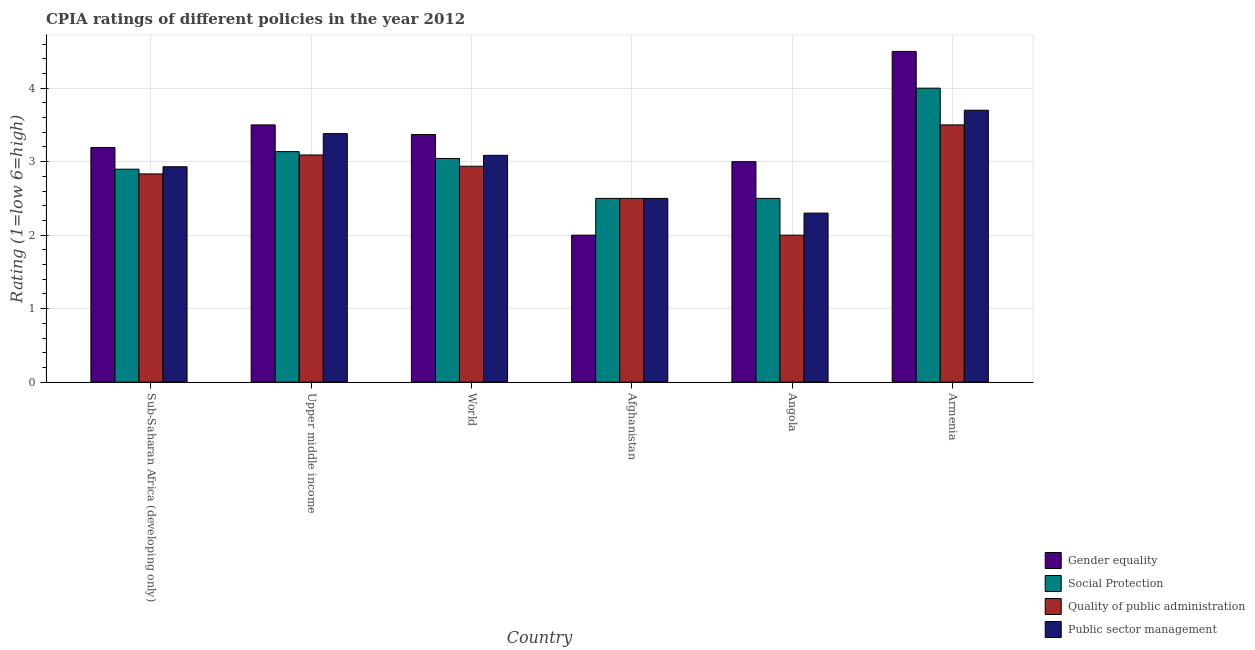How many different coloured bars are there?
Provide a succinct answer. 4. How many groups of bars are there?
Make the answer very short. 6. Are the number of bars on each tick of the X-axis equal?
Your response must be concise. Yes. How many bars are there on the 5th tick from the left?
Make the answer very short. 4. What is the label of the 6th group of bars from the left?
Make the answer very short. Armenia. In how many cases, is the number of bars for a given country not equal to the number of legend labels?
Ensure brevity in your answer.  0. Across all countries, what is the maximum cpia rating of public sector management?
Ensure brevity in your answer.  3.7. In which country was the cpia rating of public sector management maximum?
Provide a succinct answer. Armenia. In which country was the cpia rating of gender equality minimum?
Your answer should be very brief. Afghanistan. What is the total cpia rating of gender equality in the graph?
Provide a succinct answer. 19.56. What is the difference between the cpia rating of social protection in Afghanistan and that in Upper middle income?
Your response must be concise. -0.64. What is the difference between the cpia rating of public sector management in Upper middle income and the cpia rating of social protection in World?
Make the answer very short. 0.34. What is the average cpia rating of social protection per country?
Offer a very short reply. 3.01. What is the difference between the cpia rating of gender equality and cpia rating of public sector management in World?
Provide a short and direct response. 0.28. What is the ratio of the cpia rating of public sector management in Sub-Saharan Africa (developing only) to that in Upper middle income?
Ensure brevity in your answer.  0.87. Is the cpia rating of social protection in Afghanistan less than that in Armenia?
Your response must be concise. Yes. Is the difference between the cpia rating of quality of public administration in Afghanistan and Upper middle income greater than the difference between the cpia rating of public sector management in Afghanistan and Upper middle income?
Provide a succinct answer. Yes. What is the difference between the highest and the second highest cpia rating of gender equality?
Offer a very short reply. 1. Is the sum of the cpia rating of gender equality in Angola and Sub-Saharan Africa (developing only) greater than the maximum cpia rating of quality of public administration across all countries?
Your answer should be very brief. Yes. Is it the case that in every country, the sum of the cpia rating of social protection and cpia rating of quality of public administration is greater than the sum of cpia rating of gender equality and cpia rating of public sector management?
Your answer should be very brief. No. What does the 3rd bar from the left in Upper middle income represents?
Keep it short and to the point. Quality of public administration. What does the 4th bar from the right in Armenia represents?
Your answer should be very brief. Gender equality. How many countries are there in the graph?
Offer a terse response. 6. Are the values on the major ticks of Y-axis written in scientific E-notation?
Provide a succinct answer. No. Does the graph contain grids?
Keep it short and to the point. Yes. Where does the legend appear in the graph?
Your answer should be very brief. Bottom right. How many legend labels are there?
Offer a terse response. 4. How are the legend labels stacked?
Give a very brief answer. Vertical. What is the title of the graph?
Your answer should be compact. CPIA ratings of different policies in the year 2012. What is the label or title of the X-axis?
Ensure brevity in your answer.  Country. What is the label or title of the Y-axis?
Keep it short and to the point. Rating (1=low 6=high). What is the Rating (1=low 6=high) of Gender equality in Sub-Saharan Africa (developing only)?
Your response must be concise. 3.19. What is the Rating (1=low 6=high) in Social Protection in Sub-Saharan Africa (developing only)?
Keep it short and to the point. 2.9. What is the Rating (1=low 6=high) of Quality of public administration in Sub-Saharan Africa (developing only)?
Your response must be concise. 2.83. What is the Rating (1=low 6=high) in Public sector management in Sub-Saharan Africa (developing only)?
Your answer should be compact. 2.93. What is the Rating (1=low 6=high) in Gender equality in Upper middle income?
Your response must be concise. 3.5. What is the Rating (1=low 6=high) of Social Protection in Upper middle income?
Your response must be concise. 3.14. What is the Rating (1=low 6=high) in Quality of public administration in Upper middle income?
Offer a very short reply. 3.09. What is the Rating (1=low 6=high) of Public sector management in Upper middle income?
Provide a succinct answer. 3.38. What is the Rating (1=low 6=high) of Gender equality in World?
Your answer should be compact. 3.37. What is the Rating (1=low 6=high) in Social Protection in World?
Your answer should be compact. 3.04. What is the Rating (1=low 6=high) of Quality of public administration in World?
Provide a short and direct response. 2.94. What is the Rating (1=low 6=high) of Public sector management in World?
Your answer should be compact. 3.09. What is the Rating (1=low 6=high) in Gender equality in Afghanistan?
Keep it short and to the point. 2. What is the Rating (1=low 6=high) of Social Protection in Afghanistan?
Ensure brevity in your answer.  2.5. What is the Rating (1=low 6=high) in Social Protection in Angola?
Provide a short and direct response. 2.5. What is the Rating (1=low 6=high) of Public sector management in Angola?
Your response must be concise. 2.3. What is the Rating (1=low 6=high) in Gender equality in Armenia?
Provide a succinct answer. 4.5. What is the Rating (1=low 6=high) in Social Protection in Armenia?
Keep it short and to the point. 4. What is the Rating (1=low 6=high) of Quality of public administration in Armenia?
Make the answer very short. 3.5. What is the Rating (1=low 6=high) of Public sector management in Armenia?
Offer a terse response. 3.7. Across all countries, what is the maximum Rating (1=low 6=high) in Social Protection?
Make the answer very short. 4. Across all countries, what is the maximum Rating (1=low 6=high) of Quality of public administration?
Keep it short and to the point. 3.5. Across all countries, what is the maximum Rating (1=low 6=high) in Public sector management?
Provide a succinct answer. 3.7. Across all countries, what is the minimum Rating (1=low 6=high) of Quality of public administration?
Provide a short and direct response. 2. What is the total Rating (1=low 6=high) of Gender equality in the graph?
Keep it short and to the point. 19.56. What is the total Rating (1=low 6=high) in Social Protection in the graph?
Offer a terse response. 18.08. What is the total Rating (1=low 6=high) of Quality of public administration in the graph?
Give a very brief answer. 16.86. What is the total Rating (1=low 6=high) of Public sector management in the graph?
Give a very brief answer. 17.9. What is the difference between the Rating (1=low 6=high) of Gender equality in Sub-Saharan Africa (developing only) and that in Upper middle income?
Give a very brief answer. -0.31. What is the difference between the Rating (1=low 6=high) of Social Protection in Sub-Saharan Africa (developing only) and that in Upper middle income?
Give a very brief answer. -0.24. What is the difference between the Rating (1=low 6=high) in Quality of public administration in Sub-Saharan Africa (developing only) and that in Upper middle income?
Make the answer very short. -0.26. What is the difference between the Rating (1=low 6=high) of Public sector management in Sub-Saharan Africa (developing only) and that in Upper middle income?
Your answer should be very brief. -0.45. What is the difference between the Rating (1=low 6=high) of Gender equality in Sub-Saharan Africa (developing only) and that in World?
Provide a succinct answer. -0.18. What is the difference between the Rating (1=low 6=high) of Social Protection in Sub-Saharan Africa (developing only) and that in World?
Offer a very short reply. -0.15. What is the difference between the Rating (1=low 6=high) in Quality of public administration in Sub-Saharan Africa (developing only) and that in World?
Your response must be concise. -0.1. What is the difference between the Rating (1=low 6=high) of Public sector management in Sub-Saharan Africa (developing only) and that in World?
Your answer should be compact. -0.16. What is the difference between the Rating (1=low 6=high) in Gender equality in Sub-Saharan Africa (developing only) and that in Afghanistan?
Provide a short and direct response. 1.19. What is the difference between the Rating (1=low 6=high) in Social Protection in Sub-Saharan Africa (developing only) and that in Afghanistan?
Offer a terse response. 0.4. What is the difference between the Rating (1=low 6=high) of Public sector management in Sub-Saharan Africa (developing only) and that in Afghanistan?
Keep it short and to the point. 0.43. What is the difference between the Rating (1=low 6=high) in Gender equality in Sub-Saharan Africa (developing only) and that in Angola?
Ensure brevity in your answer.  0.19. What is the difference between the Rating (1=low 6=high) of Social Protection in Sub-Saharan Africa (developing only) and that in Angola?
Your answer should be compact. 0.4. What is the difference between the Rating (1=low 6=high) in Quality of public administration in Sub-Saharan Africa (developing only) and that in Angola?
Ensure brevity in your answer.  0.83. What is the difference between the Rating (1=low 6=high) of Public sector management in Sub-Saharan Africa (developing only) and that in Angola?
Provide a succinct answer. 0.63. What is the difference between the Rating (1=low 6=high) in Gender equality in Sub-Saharan Africa (developing only) and that in Armenia?
Provide a succinct answer. -1.31. What is the difference between the Rating (1=low 6=high) in Social Protection in Sub-Saharan Africa (developing only) and that in Armenia?
Provide a short and direct response. -1.1. What is the difference between the Rating (1=low 6=high) in Quality of public administration in Sub-Saharan Africa (developing only) and that in Armenia?
Offer a terse response. -0.67. What is the difference between the Rating (1=low 6=high) of Public sector management in Sub-Saharan Africa (developing only) and that in Armenia?
Provide a succinct answer. -0.77. What is the difference between the Rating (1=low 6=high) in Gender equality in Upper middle income and that in World?
Ensure brevity in your answer.  0.13. What is the difference between the Rating (1=low 6=high) in Social Protection in Upper middle income and that in World?
Provide a short and direct response. 0.09. What is the difference between the Rating (1=low 6=high) in Quality of public administration in Upper middle income and that in World?
Give a very brief answer. 0.15. What is the difference between the Rating (1=low 6=high) in Public sector management in Upper middle income and that in World?
Make the answer very short. 0.3. What is the difference between the Rating (1=low 6=high) of Gender equality in Upper middle income and that in Afghanistan?
Give a very brief answer. 1.5. What is the difference between the Rating (1=low 6=high) of Social Protection in Upper middle income and that in Afghanistan?
Provide a short and direct response. 0.64. What is the difference between the Rating (1=low 6=high) of Quality of public administration in Upper middle income and that in Afghanistan?
Your answer should be very brief. 0.59. What is the difference between the Rating (1=low 6=high) in Public sector management in Upper middle income and that in Afghanistan?
Your response must be concise. 0.88. What is the difference between the Rating (1=low 6=high) of Social Protection in Upper middle income and that in Angola?
Provide a short and direct response. 0.64. What is the difference between the Rating (1=low 6=high) of Public sector management in Upper middle income and that in Angola?
Provide a succinct answer. 1.08. What is the difference between the Rating (1=low 6=high) in Gender equality in Upper middle income and that in Armenia?
Your response must be concise. -1. What is the difference between the Rating (1=low 6=high) in Social Protection in Upper middle income and that in Armenia?
Ensure brevity in your answer.  -0.86. What is the difference between the Rating (1=low 6=high) in Quality of public administration in Upper middle income and that in Armenia?
Give a very brief answer. -0.41. What is the difference between the Rating (1=low 6=high) in Public sector management in Upper middle income and that in Armenia?
Offer a very short reply. -0.32. What is the difference between the Rating (1=low 6=high) in Gender equality in World and that in Afghanistan?
Give a very brief answer. 1.37. What is the difference between the Rating (1=low 6=high) of Social Protection in World and that in Afghanistan?
Give a very brief answer. 0.54. What is the difference between the Rating (1=low 6=high) of Quality of public administration in World and that in Afghanistan?
Offer a very short reply. 0.44. What is the difference between the Rating (1=low 6=high) in Public sector management in World and that in Afghanistan?
Ensure brevity in your answer.  0.59. What is the difference between the Rating (1=low 6=high) of Gender equality in World and that in Angola?
Your answer should be compact. 0.37. What is the difference between the Rating (1=low 6=high) of Social Protection in World and that in Angola?
Offer a terse response. 0.54. What is the difference between the Rating (1=low 6=high) in Public sector management in World and that in Angola?
Ensure brevity in your answer.  0.79. What is the difference between the Rating (1=low 6=high) in Gender equality in World and that in Armenia?
Make the answer very short. -1.13. What is the difference between the Rating (1=low 6=high) of Social Protection in World and that in Armenia?
Provide a succinct answer. -0.96. What is the difference between the Rating (1=low 6=high) of Quality of public administration in World and that in Armenia?
Give a very brief answer. -0.56. What is the difference between the Rating (1=low 6=high) in Public sector management in World and that in Armenia?
Offer a terse response. -0.61. What is the difference between the Rating (1=low 6=high) in Social Protection in Afghanistan and that in Angola?
Provide a succinct answer. 0. What is the difference between the Rating (1=low 6=high) in Public sector management in Afghanistan and that in Angola?
Make the answer very short. 0.2. What is the difference between the Rating (1=low 6=high) of Gender equality in Afghanistan and that in Armenia?
Your answer should be very brief. -2.5. What is the difference between the Rating (1=low 6=high) in Gender equality in Angola and that in Armenia?
Offer a very short reply. -1.5. What is the difference between the Rating (1=low 6=high) in Gender equality in Sub-Saharan Africa (developing only) and the Rating (1=low 6=high) in Social Protection in Upper middle income?
Offer a very short reply. 0.06. What is the difference between the Rating (1=low 6=high) of Gender equality in Sub-Saharan Africa (developing only) and the Rating (1=low 6=high) of Quality of public administration in Upper middle income?
Offer a terse response. 0.1. What is the difference between the Rating (1=low 6=high) in Gender equality in Sub-Saharan Africa (developing only) and the Rating (1=low 6=high) in Public sector management in Upper middle income?
Provide a short and direct response. -0.19. What is the difference between the Rating (1=low 6=high) of Social Protection in Sub-Saharan Africa (developing only) and the Rating (1=low 6=high) of Quality of public administration in Upper middle income?
Ensure brevity in your answer.  -0.19. What is the difference between the Rating (1=low 6=high) in Social Protection in Sub-Saharan Africa (developing only) and the Rating (1=low 6=high) in Public sector management in Upper middle income?
Provide a short and direct response. -0.48. What is the difference between the Rating (1=low 6=high) of Quality of public administration in Sub-Saharan Africa (developing only) and the Rating (1=low 6=high) of Public sector management in Upper middle income?
Make the answer very short. -0.55. What is the difference between the Rating (1=low 6=high) in Gender equality in Sub-Saharan Africa (developing only) and the Rating (1=low 6=high) in Social Protection in World?
Offer a very short reply. 0.15. What is the difference between the Rating (1=low 6=high) in Gender equality in Sub-Saharan Africa (developing only) and the Rating (1=low 6=high) in Quality of public administration in World?
Ensure brevity in your answer.  0.25. What is the difference between the Rating (1=low 6=high) of Gender equality in Sub-Saharan Africa (developing only) and the Rating (1=low 6=high) of Public sector management in World?
Provide a succinct answer. 0.11. What is the difference between the Rating (1=low 6=high) of Social Protection in Sub-Saharan Africa (developing only) and the Rating (1=low 6=high) of Quality of public administration in World?
Offer a terse response. -0.04. What is the difference between the Rating (1=low 6=high) of Social Protection in Sub-Saharan Africa (developing only) and the Rating (1=low 6=high) of Public sector management in World?
Offer a very short reply. -0.19. What is the difference between the Rating (1=low 6=high) of Quality of public administration in Sub-Saharan Africa (developing only) and the Rating (1=low 6=high) of Public sector management in World?
Provide a succinct answer. -0.25. What is the difference between the Rating (1=low 6=high) of Gender equality in Sub-Saharan Africa (developing only) and the Rating (1=low 6=high) of Social Protection in Afghanistan?
Ensure brevity in your answer.  0.69. What is the difference between the Rating (1=low 6=high) in Gender equality in Sub-Saharan Africa (developing only) and the Rating (1=low 6=high) in Quality of public administration in Afghanistan?
Offer a terse response. 0.69. What is the difference between the Rating (1=low 6=high) in Gender equality in Sub-Saharan Africa (developing only) and the Rating (1=low 6=high) in Public sector management in Afghanistan?
Give a very brief answer. 0.69. What is the difference between the Rating (1=low 6=high) in Social Protection in Sub-Saharan Africa (developing only) and the Rating (1=low 6=high) in Quality of public administration in Afghanistan?
Give a very brief answer. 0.4. What is the difference between the Rating (1=low 6=high) of Social Protection in Sub-Saharan Africa (developing only) and the Rating (1=low 6=high) of Public sector management in Afghanistan?
Offer a terse response. 0.4. What is the difference between the Rating (1=low 6=high) of Gender equality in Sub-Saharan Africa (developing only) and the Rating (1=low 6=high) of Social Protection in Angola?
Give a very brief answer. 0.69. What is the difference between the Rating (1=low 6=high) of Gender equality in Sub-Saharan Africa (developing only) and the Rating (1=low 6=high) of Quality of public administration in Angola?
Your answer should be compact. 1.19. What is the difference between the Rating (1=low 6=high) in Gender equality in Sub-Saharan Africa (developing only) and the Rating (1=low 6=high) in Public sector management in Angola?
Your answer should be compact. 0.89. What is the difference between the Rating (1=low 6=high) of Social Protection in Sub-Saharan Africa (developing only) and the Rating (1=low 6=high) of Quality of public administration in Angola?
Ensure brevity in your answer.  0.9. What is the difference between the Rating (1=low 6=high) of Social Protection in Sub-Saharan Africa (developing only) and the Rating (1=low 6=high) of Public sector management in Angola?
Provide a succinct answer. 0.6. What is the difference between the Rating (1=low 6=high) of Quality of public administration in Sub-Saharan Africa (developing only) and the Rating (1=low 6=high) of Public sector management in Angola?
Ensure brevity in your answer.  0.53. What is the difference between the Rating (1=low 6=high) of Gender equality in Sub-Saharan Africa (developing only) and the Rating (1=low 6=high) of Social Protection in Armenia?
Ensure brevity in your answer.  -0.81. What is the difference between the Rating (1=low 6=high) of Gender equality in Sub-Saharan Africa (developing only) and the Rating (1=low 6=high) of Quality of public administration in Armenia?
Provide a succinct answer. -0.31. What is the difference between the Rating (1=low 6=high) in Gender equality in Sub-Saharan Africa (developing only) and the Rating (1=low 6=high) in Public sector management in Armenia?
Your answer should be compact. -0.51. What is the difference between the Rating (1=low 6=high) of Social Protection in Sub-Saharan Africa (developing only) and the Rating (1=low 6=high) of Quality of public administration in Armenia?
Your response must be concise. -0.6. What is the difference between the Rating (1=low 6=high) of Social Protection in Sub-Saharan Africa (developing only) and the Rating (1=low 6=high) of Public sector management in Armenia?
Ensure brevity in your answer.  -0.8. What is the difference between the Rating (1=low 6=high) in Quality of public administration in Sub-Saharan Africa (developing only) and the Rating (1=low 6=high) in Public sector management in Armenia?
Provide a short and direct response. -0.87. What is the difference between the Rating (1=low 6=high) of Gender equality in Upper middle income and the Rating (1=low 6=high) of Social Protection in World?
Provide a short and direct response. 0.46. What is the difference between the Rating (1=low 6=high) of Gender equality in Upper middle income and the Rating (1=low 6=high) of Quality of public administration in World?
Keep it short and to the point. 0.56. What is the difference between the Rating (1=low 6=high) in Gender equality in Upper middle income and the Rating (1=low 6=high) in Public sector management in World?
Provide a succinct answer. 0.41. What is the difference between the Rating (1=low 6=high) in Social Protection in Upper middle income and the Rating (1=low 6=high) in Quality of public administration in World?
Keep it short and to the point. 0.2. What is the difference between the Rating (1=low 6=high) of Social Protection in Upper middle income and the Rating (1=low 6=high) of Public sector management in World?
Give a very brief answer. 0.05. What is the difference between the Rating (1=low 6=high) of Quality of public administration in Upper middle income and the Rating (1=low 6=high) of Public sector management in World?
Your answer should be very brief. 0. What is the difference between the Rating (1=low 6=high) of Gender equality in Upper middle income and the Rating (1=low 6=high) of Quality of public administration in Afghanistan?
Ensure brevity in your answer.  1. What is the difference between the Rating (1=low 6=high) of Gender equality in Upper middle income and the Rating (1=low 6=high) of Public sector management in Afghanistan?
Ensure brevity in your answer.  1. What is the difference between the Rating (1=low 6=high) of Social Protection in Upper middle income and the Rating (1=low 6=high) of Quality of public administration in Afghanistan?
Make the answer very short. 0.64. What is the difference between the Rating (1=low 6=high) of Social Protection in Upper middle income and the Rating (1=low 6=high) of Public sector management in Afghanistan?
Offer a very short reply. 0.64. What is the difference between the Rating (1=low 6=high) in Quality of public administration in Upper middle income and the Rating (1=low 6=high) in Public sector management in Afghanistan?
Your answer should be very brief. 0.59. What is the difference between the Rating (1=low 6=high) in Gender equality in Upper middle income and the Rating (1=low 6=high) in Social Protection in Angola?
Offer a very short reply. 1. What is the difference between the Rating (1=low 6=high) of Gender equality in Upper middle income and the Rating (1=low 6=high) of Public sector management in Angola?
Ensure brevity in your answer.  1.2. What is the difference between the Rating (1=low 6=high) of Social Protection in Upper middle income and the Rating (1=low 6=high) of Quality of public administration in Angola?
Offer a terse response. 1.14. What is the difference between the Rating (1=low 6=high) of Social Protection in Upper middle income and the Rating (1=low 6=high) of Public sector management in Angola?
Keep it short and to the point. 0.84. What is the difference between the Rating (1=low 6=high) of Quality of public administration in Upper middle income and the Rating (1=low 6=high) of Public sector management in Angola?
Ensure brevity in your answer.  0.79. What is the difference between the Rating (1=low 6=high) of Gender equality in Upper middle income and the Rating (1=low 6=high) of Social Protection in Armenia?
Give a very brief answer. -0.5. What is the difference between the Rating (1=low 6=high) of Gender equality in Upper middle income and the Rating (1=low 6=high) of Public sector management in Armenia?
Give a very brief answer. -0.2. What is the difference between the Rating (1=low 6=high) in Social Protection in Upper middle income and the Rating (1=low 6=high) in Quality of public administration in Armenia?
Make the answer very short. -0.36. What is the difference between the Rating (1=low 6=high) of Social Protection in Upper middle income and the Rating (1=low 6=high) of Public sector management in Armenia?
Your answer should be compact. -0.56. What is the difference between the Rating (1=low 6=high) of Quality of public administration in Upper middle income and the Rating (1=low 6=high) of Public sector management in Armenia?
Keep it short and to the point. -0.61. What is the difference between the Rating (1=low 6=high) in Gender equality in World and the Rating (1=low 6=high) in Social Protection in Afghanistan?
Your response must be concise. 0.87. What is the difference between the Rating (1=low 6=high) of Gender equality in World and the Rating (1=low 6=high) of Quality of public administration in Afghanistan?
Ensure brevity in your answer.  0.87. What is the difference between the Rating (1=low 6=high) of Gender equality in World and the Rating (1=low 6=high) of Public sector management in Afghanistan?
Give a very brief answer. 0.87. What is the difference between the Rating (1=low 6=high) of Social Protection in World and the Rating (1=low 6=high) of Quality of public administration in Afghanistan?
Offer a very short reply. 0.54. What is the difference between the Rating (1=low 6=high) of Social Protection in World and the Rating (1=low 6=high) of Public sector management in Afghanistan?
Make the answer very short. 0.54. What is the difference between the Rating (1=low 6=high) of Quality of public administration in World and the Rating (1=low 6=high) of Public sector management in Afghanistan?
Offer a terse response. 0.44. What is the difference between the Rating (1=low 6=high) in Gender equality in World and the Rating (1=low 6=high) in Social Protection in Angola?
Provide a short and direct response. 0.87. What is the difference between the Rating (1=low 6=high) of Gender equality in World and the Rating (1=low 6=high) of Quality of public administration in Angola?
Keep it short and to the point. 1.37. What is the difference between the Rating (1=low 6=high) in Gender equality in World and the Rating (1=low 6=high) in Public sector management in Angola?
Provide a succinct answer. 1.07. What is the difference between the Rating (1=low 6=high) in Social Protection in World and the Rating (1=low 6=high) in Quality of public administration in Angola?
Provide a succinct answer. 1.04. What is the difference between the Rating (1=low 6=high) of Social Protection in World and the Rating (1=low 6=high) of Public sector management in Angola?
Your answer should be compact. 0.74. What is the difference between the Rating (1=low 6=high) in Quality of public administration in World and the Rating (1=low 6=high) in Public sector management in Angola?
Provide a succinct answer. 0.64. What is the difference between the Rating (1=low 6=high) of Gender equality in World and the Rating (1=low 6=high) of Social Protection in Armenia?
Offer a terse response. -0.63. What is the difference between the Rating (1=low 6=high) of Gender equality in World and the Rating (1=low 6=high) of Quality of public administration in Armenia?
Your answer should be very brief. -0.13. What is the difference between the Rating (1=low 6=high) in Gender equality in World and the Rating (1=low 6=high) in Public sector management in Armenia?
Ensure brevity in your answer.  -0.33. What is the difference between the Rating (1=low 6=high) in Social Protection in World and the Rating (1=low 6=high) in Quality of public administration in Armenia?
Ensure brevity in your answer.  -0.46. What is the difference between the Rating (1=low 6=high) of Social Protection in World and the Rating (1=low 6=high) of Public sector management in Armenia?
Offer a very short reply. -0.66. What is the difference between the Rating (1=low 6=high) in Quality of public administration in World and the Rating (1=low 6=high) in Public sector management in Armenia?
Offer a terse response. -0.76. What is the difference between the Rating (1=low 6=high) in Gender equality in Afghanistan and the Rating (1=low 6=high) in Social Protection in Angola?
Your answer should be very brief. -0.5. What is the difference between the Rating (1=low 6=high) of Gender equality in Afghanistan and the Rating (1=low 6=high) of Quality of public administration in Angola?
Provide a short and direct response. 0. What is the difference between the Rating (1=low 6=high) of Social Protection in Afghanistan and the Rating (1=low 6=high) of Public sector management in Angola?
Provide a short and direct response. 0.2. What is the difference between the Rating (1=low 6=high) of Quality of public administration in Afghanistan and the Rating (1=low 6=high) of Public sector management in Angola?
Give a very brief answer. 0.2. What is the difference between the Rating (1=low 6=high) of Gender equality in Afghanistan and the Rating (1=low 6=high) of Social Protection in Armenia?
Your response must be concise. -2. What is the difference between the Rating (1=low 6=high) in Gender equality in Afghanistan and the Rating (1=low 6=high) in Public sector management in Armenia?
Your answer should be compact. -1.7. What is the difference between the Rating (1=low 6=high) in Social Protection in Afghanistan and the Rating (1=low 6=high) in Public sector management in Armenia?
Provide a succinct answer. -1.2. What is the difference between the Rating (1=low 6=high) in Quality of public administration in Afghanistan and the Rating (1=low 6=high) in Public sector management in Armenia?
Give a very brief answer. -1.2. What is the difference between the Rating (1=low 6=high) of Gender equality in Angola and the Rating (1=low 6=high) of Social Protection in Armenia?
Offer a terse response. -1. What is the difference between the Rating (1=low 6=high) of Gender equality in Angola and the Rating (1=low 6=high) of Quality of public administration in Armenia?
Provide a short and direct response. -0.5. What is the difference between the Rating (1=low 6=high) of Gender equality in Angola and the Rating (1=low 6=high) of Public sector management in Armenia?
Keep it short and to the point. -0.7. What is the difference between the Rating (1=low 6=high) in Social Protection in Angola and the Rating (1=low 6=high) in Quality of public administration in Armenia?
Your response must be concise. -1. What is the difference between the Rating (1=low 6=high) of Social Protection in Angola and the Rating (1=low 6=high) of Public sector management in Armenia?
Your response must be concise. -1.2. What is the difference between the Rating (1=low 6=high) of Quality of public administration in Angola and the Rating (1=low 6=high) of Public sector management in Armenia?
Make the answer very short. -1.7. What is the average Rating (1=low 6=high) of Gender equality per country?
Provide a short and direct response. 3.26. What is the average Rating (1=low 6=high) in Social Protection per country?
Keep it short and to the point. 3.01. What is the average Rating (1=low 6=high) in Quality of public administration per country?
Provide a short and direct response. 2.81. What is the average Rating (1=low 6=high) in Public sector management per country?
Your response must be concise. 2.98. What is the difference between the Rating (1=low 6=high) of Gender equality and Rating (1=low 6=high) of Social Protection in Sub-Saharan Africa (developing only)?
Keep it short and to the point. 0.29. What is the difference between the Rating (1=low 6=high) in Gender equality and Rating (1=low 6=high) in Quality of public administration in Sub-Saharan Africa (developing only)?
Offer a very short reply. 0.36. What is the difference between the Rating (1=low 6=high) in Gender equality and Rating (1=low 6=high) in Public sector management in Sub-Saharan Africa (developing only)?
Offer a very short reply. 0.26. What is the difference between the Rating (1=low 6=high) of Social Protection and Rating (1=low 6=high) of Quality of public administration in Sub-Saharan Africa (developing only)?
Provide a short and direct response. 0.06. What is the difference between the Rating (1=low 6=high) in Social Protection and Rating (1=low 6=high) in Public sector management in Sub-Saharan Africa (developing only)?
Give a very brief answer. -0.03. What is the difference between the Rating (1=low 6=high) in Quality of public administration and Rating (1=low 6=high) in Public sector management in Sub-Saharan Africa (developing only)?
Provide a short and direct response. -0.1. What is the difference between the Rating (1=low 6=high) of Gender equality and Rating (1=low 6=high) of Social Protection in Upper middle income?
Your answer should be very brief. 0.36. What is the difference between the Rating (1=low 6=high) of Gender equality and Rating (1=low 6=high) of Quality of public administration in Upper middle income?
Ensure brevity in your answer.  0.41. What is the difference between the Rating (1=low 6=high) of Gender equality and Rating (1=low 6=high) of Public sector management in Upper middle income?
Make the answer very short. 0.12. What is the difference between the Rating (1=low 6=high) of Social Protection and Rating (1=low 6=high) of Quality of public administration in Upper middle income?
Offer a very short reply. 0.05. What is the difference between the Rating (1=low 6=high) in Social Protection and Rating (1=low 6=high) in Public sector management in Upper middle income?
Your answer should be compact. -0.25. What is the difference between the Rating (1=low 6=high) in Quality of public administration and Rating (1=low 6=high) in Public sector management in Upper middle income?
Offer a very short reply. -0.29. What is the difference between the Rating (1=low 6=high) of Gender equality and Rating (1=low 6=high) of Social Protection in World?
Your answer should be very brief. 0.33. What is the difference between the Rating (1=low 6=high) of Gender equality and Rating (1=low 6=high) of Quality of public administration in World?
Ensure brevity in your answer.  0.43. What is the difference between the Rating (1=low 6=high) of Gender equality and Rating (1=low 6=high) of Public sector management in World?
Provide a short and direct response. 0.28. What is the difference between the Rating (1=low 6=high) in Social Protection and Rating (1=low 6=high) in Quality of public administration in World?
Keep it short and to the point. 0.11. What is the difference between the Rating (1=low 6=high) of Social Protection and Rating (1=low 6=high) of Public sector management in World?
Offer a terse response. -0.04. What is the difference between the Rating (1=low 6=high) in Quality of public administration and Rating (1=low 6=high) in Public sector management in World?
Your answer should be compact. -0.15. What is the difference between the Rating (1=low 6=high) of Gender equality and Rating (1=low 6=high) of Social Protection in Afghanistan?
Keep it short and to the point. -0.5. What is the difference between the Rating (1=low 6=high) in Gender equality and Rating (1=low 6=high) in Quality of public administration in Afghanistan?
Your answer should be very brief. -0.5. What is the difference between the Rating (1=low 6=high) of Gender equality and Rating (1=low 6=high) of Public sector management in Afghanistan?
Your answer should be very brief. -0.5. What is the difference between the Rating (1=low 6=high) of Social Protection and Rating (1=low 6=high) of Quality of public administration in Afghanistan?
Provide a succinct answer. 0. What is the difference between the Rating (1=low 6=high) in Social Protection and Rating (1=low 6=high) in Quality of public administration in Angola?
Keep it short and to the point. 0.5. What is the difference between the Rating (1=low 6=high) in Social Protection and Rating (1=low 6=high) in Public sector management in Angola?
Provide a short and direct response. 0.2. What is the difference between the Rating (1=low 6=high) in Quality of public administration and Rating (1=low 6=high) in Public sector management in Angola?
Offer a very short reply. -0.3. What is the difference between the Rating (1=low 6=high) in Gender equality and Rating (1=low 6=high) in Social Protection in Armenia?
Keep it short and to the point. 0.5. What is the difference between the Rating (1=low 6=high) in Gender equality and Rating (1=low 6=high) in Quality of public administration in Armenia?
Offer a very short reply. 1. What is the difference between the Rating (1=low 6=high) of Gender equality and Rating (1=low 6=high) of Public sector management in Armenia?
Your response must be concise. 0.8. What is the difference between the Rating (1=low 6=high) in Social Protection and Rating (1=low 6=high) in Quality of public administration in Armenia?
Your answer should be compact. 0.5. What is the difference between the Rating (1=low 6=high) of Quality of public administration and Rating (1=low 6=high) of Public sector management in Armenia?
Offer a terse response. -0.2. What is the ratio of the Rating (1=low 6=high) of Gender equality in Sub-Saharan Africa (developing only) to that in Upper middle income?
Offer a very short reply. 0.91. What is the ratio of the Rating (1=low 6=high) of Social Protection in Sub-Saharan Africa (developing only) to that in Upper middle income?
Offer a terse response. 0.92. What is the ratio of the Rating (1=low 6=high) of Public sector management in Sub-Saharan Africa (developing only) to that in Upper middle income?
Your response must be concise. 0.87. What is the ratio of the Rating (1=low 6=high) of Gender equality in Sub-Saharan Africa (developing only) to that in World?
Offer a very short reply. 0.95. What is the ratio of the Rating (1=low 6=high) in Social Protection in Sub-Saharan Africa (developing only) to that in World?
Give a very brief answer. 0.95. What is the ratio of the Rating (1=low 6=high) of Quality of public administration in Sub-Saharan Africa (developing only) to that in World?
Make the answer very short. 0.96. What is the ratio of the Rating (1=low 6=high) of Public sector management in Sub-Saharan Africa (developing only) to that in World?
Ensure brevity in your answer.  0.95. What is the ratio of the Rating (1=low 6=high) in Gender equality in Sub-Saharan Africa (developing only) to that in Afghanistan?
Your answer should be compact. 1.6. What is the ratio of the Rating (1=low 6=high) of Social Protection in Sub-Saharan Africa (developing only) to that in Afghanistan?
Offer a terse response. 1.16. What is the ratio of the Rating (1=low 6=high) in Quality of public administration in Sub-Saharan Africa (developing only) to that in Afghanistan?
Provide a succinct answer. 1.13. What is the ratio of the Rating (1=low 6=high) of Public sector management in Sub-Saharan Africa (developing only) to that in Afghanistan?
Your response must be concise. 1.17. What is the ratio of the Rating (1=low 6=high) of Gender equality in Sub-Saharan Africa (developing only) to that in Angola?
Your answer should be very brief. 1.06. What is the ratio of the Rating (1=low 6=high) of Social Protection in Sub-Saharan Africa (developing only) to that in Angola?
Your answer should be compact. 1.16. What is the ratio of the Rating (1=low 6=high) in Quality of public administration in Sub-Saharan Africa (developing only) to that in Angola?
Provide a succinct answer. 1.42. What is the ratio of the Rating (1=low 6=high) of Public sector management in Sub-Saharan Africa (developing only) to that in Angola?
Give a very brief answer. 1.27. What is the ratio of the Rating (1=low 6=high) in Gender equality in Sub-Saharan Africa (developing only) to that in Armenia?
Provide a short and direct response. 0.71. What is the ratio of the Rating (1=low 6=high) of Social Protection in Sub-Saharan Africa (developing only) to that in Armenia?
Your answer should be very brief. 0.72. What is the ratio of the Rating (1=low 6=high) in Quality of public administration in Sub-Saharan Africa (developing only) to that in Armenia?
Your answer should be very brief. 0.81. What is the ratio of the Rating (1=low 6=high) in Public sector management in Sub-Saharan Africa (developing only) to that in Armenia?
Give a very brief answer. 0.79. What is the ratio of the Rating (1=low 6=high) in Gender equality in Upper middle income to that in World?
Keep it short and to the point. 1.04. What is the ratio of the Rating (1=low 6=high) of Social Protection in Upper middle income to that in World?
Give a very brief answer. 1.03. What is the ratio of the Rating (1=low 6=high) of Quality of public administration in Upper middle income to that in World?
Provide a succinct answer. 1.05. What is the ratio of the Rating (1=low 6=high) of Public sector management in Upper middle income to that in World?
Offer a very short reply. 1.1. What is the ratio of the Rating (1=low 6=high) in Social Protection in Upper middle income to that in Afghanistan?
Ensure brevity in your answer.  1.25. What is the ratio of the Rating (1=low 6=high) in Quality of public administration in Upper middle income to that in Afghanistan?
Offer a terse response. 1.24. What is the ratio of the Rating (1=low 6=high) in Public sector management in Upper middle income to that in Afghanistan?
Your answer should be compact. 1.35. What is the ratio of the Rating (1=low 6=high) in Social Protection in Upper middle income to that in Angola?
Ensure brevity in your answer.  1.25. What is the ratio of the Rating (1=low 6=high) in Quality of public administration in Upper middle income to that in Angola?
Your answer should be compact. 1.55. What is the ratio of the Rating (1=low 6=high) in Public sector management in Upper middle income to that in Angola?
Keep it short and to the point. 1.47. What is the ratio of the Rating (1=low 6=high) in Social Protection in Upper middle income to that in Armenia?
Provide a short and direct response. 0.78. What is the ratio of the Rating (1=low 6=high) of Quality of public administration in Upper middle income to that in Armenia?
Your answer should be compact. 0.88. What is the ratio of the Rating (1=low 6=high) of Public sector management in Upper middle income to that in Armenia?
Ensure brevity in your answer.  0.91. What is the ratio of the Rating (1=low 6=high) in Gender equality in World to that in Afghanistan?
Provide a succinct answer. 1.68. What is the ratio of the Rating (1=low 6=high) of Social Protection in World to that in Afghanistan?
Offer a terse response. 1.22. What is the ratio of the Rating (1=low 6=high) of Quality of public administration in World to that in Afghanistan?
Your response must be concise. 1.18. What is the ratio of the Rating (1=low 6=high) of Public sector management in World to that in Afghanistan?
Offer a very short reply. 1.23. What is the ratio of the Rating (1=low 6=high) of Gender equality in World to that in Angola?
Offer a terse response. 1.12. What is the ratio of the Rating (1=low 6=high) in Social Protection in World to that in Angola?
Make the answer very short. 1.22. What is the ratio of the Rating (1=low 6=high) in Quality of public administration in World to that in Angola?
Provide a short and direct response. 1.47. What is the ratio of the Rating (1=low 6=high) of Public sector management in World to that in Angola?
Give a very brief answer. 1.34. What is the ratio of the Rating (1=low 6=high) in Gender equality in World to that in Armenia?
Your answer should be compact. 0.75. What is the ratio of the Rating (1=low 6=high) in Social Protection in World to that in Armenia?
Your answer should be compact. 0.76. What is the ratio of the Rating (1=low 6=high) in Quality of public administration in World to that in Armenia?
Offer a very short reply. 0.84. What is the ratio of the Rating (1=low 6=high) of Public sector management in World to that in Armenia?
Provide a short and direct response. 0.83. What is the ratio of the Rating (1=low 6=high) of Social Protection in Afghanistan to that in Angola?
Provide a short and direct response. 1. What is the ratio of the Rating (1=low 6=high) in Quality of public administration in Afghanistan to that in Angola?
Provide a short and direct response. 1.25. What is the ratio of the Rating (1=low 6=high) of Public sector management in Afghanistan to that in Angola?
Offer a very short reply. 1.09. What is the ratio of the Rating (1=low 6=high) in Gender equality in Afghanistan to that in Armenia?
Give a very brief answer. 0.44. What is the ratio of the Rating (1=low 6=high) in Public sector management in Afghanistan to that in Armenia?
Provide a short and direct response. 0.68. What is the ratio of the Rating (1=low 6=high) in Gender equality in Angola to that in Armenia?
Ensure brevity in your answer.  0.67. What is the ratio of the Rating (1=low 6=high) in Public sector management in Angola to that in Armenia?
Your answer should be compact. 0.62. What is the difference between the highest and the second highest Rating (1=low 6=high) of Social Protection?
Ensure brevity in your answer.  0.86. What is the difference between the highest and the second highest Rating (1=low 6=high) of Quality of public administration?
Offer a very short reply. 0.41. What is the difference between the highest and the second highest Rating (1=low 6=high) of Public sector management?
Make the answer very short. 0.32. What is the difference between the highest and the lowest Rating (1=low 6=high) of Gender equality?
Offer a very short reply. 2.5. 